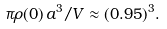Convert formula to latex. <formula><loc_0><loc_0><loc_500><loc_500>\pi \rho ( 0 ) \, a ^ { 3 } / V \approx ( 0 . 9 5 ) ^ { 3 } .</formula> 